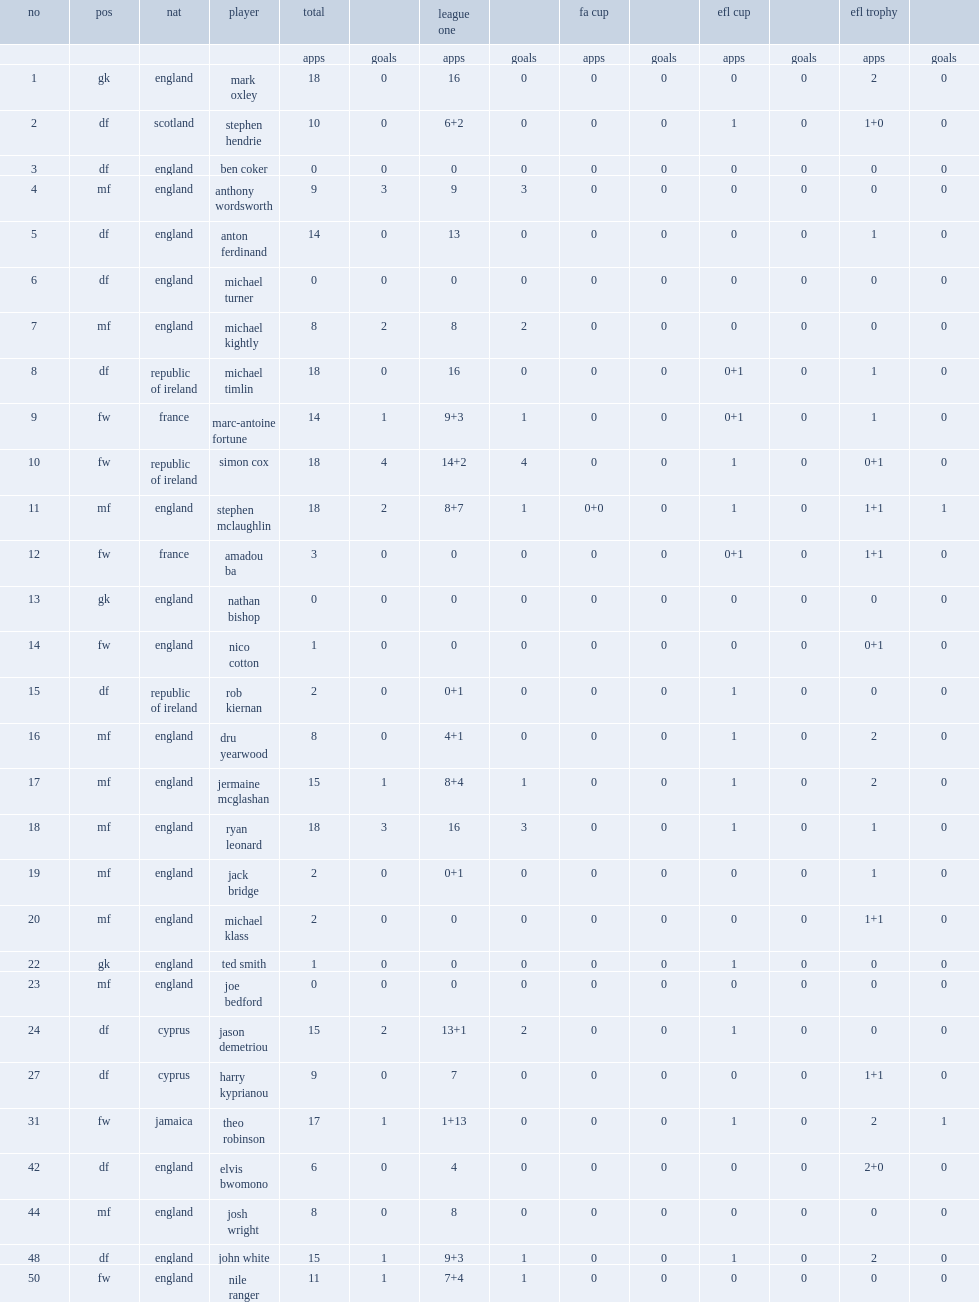Write the full table. {'header': ['no', 'pos', 'nat', 'player', 'total', '', 'league one', '', 'fa cup', '', 'efl cup', '', 'efl trophy', ''], 'rows': [['', '', '', '', 'apps', 'goals', 'apps', 'goals', 'apps', 'goals', 'apps', 'goals', 'apps', 'goals'], ['1', 'gk', 'england', 'mark oxley', '18', '0', '16', '0', '0', '0', '0', '0', '2', '0'], ['2', 'df', 'scotland', 'stephen hendrie', '10', '0', '6+2', '0', '0', '0', '1', '0', '1+0', '0'], ['3', 'df', 'england', 'ben coker', '0', '0', '0', '0', '0', '0', '0', '0', '0', '0'], ['4', 'mf', 'england', 'anthony wordsworth', '9', '3', '9', '3', '0', '0', '0', '0', '0', '0'], ['5', 'df', 'england', 'anton ferdinand', '14', '0', '13', '0', '0', '0', '0', '0', '1', '0'], ['6', 'df', 'england', 'michael turner', '0', '0', '0', '0', '0', '0', '0', '0', '0', '0'], ['7', 'mf', 'england', 'michael kightly', '8', '2', '8', '2', '0', '0', '0', '0', '0', '0'], ['8', 'df', 'republic of ireland', 'michael timlin', '18', '0', '16', '0', '0', '0', '0+1', '0', '1', '0'], ['9', 'fw', 'france', 'marc-antoine fortune', '14', '1', '9+3', '1', '0', '0', '0+1', '0', '1', '0'], ['10', 'fw', 'republic of ireland', 'simon cox', '18', '4', '14+2', '4', '0', '0', '1', '0', '0+1', '0'], ['11', 'mf', 'england', 'stephen mclaughlin', '18', '2', '8+7', '1', '0+0', '0', '1', '0', '1+1', '1'], ['12', 'fw', 'france', 'amadou ba', '3', '0', '0', '0', '0', '0', '0+1', '0', '1+1', '0'], ['13', 'gk', 'england', 'nathan bishop', '0', '0', '0', '0', '0', '0', '0', '0', '0', '0'], ['14', 'fw', 'england', 'nico cotton', '1', '0', '0', '0', '0', '0', '0', '0', '0+1', '0'], ['15', 'df', 'republic of ireland', 'rob kiernan', '2', '0', '0+1', '0', '0', '0', '1', '0', '0', '0'], ['16', 'mf', 'england', 'dru yearwood', '8', '0', '4+1', '0', '0', '0', '1', '0', '2', '0'], ['17', 'mf', 'england', 'jermaine mcglashan', '15', '1', '8+4', '1', '0', '0', '1', '0', '2', '0'], ['18', 'mf', 'england', 'ryan leonard', '18', '3', '16', '3', '0', '0', '1', '0', '1', '0'], ['19', 'mf', 'england', 'jack bridge', '2', '0', '0+1', '0', '0', '0', '0', '0', '1', '0'], ['20', 'mf', 'england', 'michael klass', '2', '0', '0', '0', '0', '0', '0', '0', '1+1', '0'], ['22', 'gk', 'england', 'ted smith', '1', '0', '0', '0', '0', '0', '1', '0', '0', '0'], ['23', 'mf', 'england', 'joe bedford', '0', '0', '0', '0', '0', '0', '0', '0', '0', '0'], ['24', 'df', 'cyprus', 'jason demetriou', '15', '2', '13+1', '2', '0', '0', '1', '0', '0', '0'], ['27', 'df', 'cyprus', 'harry kyprianou', '9', '0', '7', '0', '0', '0', '0', '0', '1+1', '0'], ['31', 'fw', 'jamaica', 'theo robinson', '17', '1', '1+13', '0', '0', '0', '1', '0', '2', '1'], ['42', 'df', 'england', 'elvis bwomono', '6', '0', '4', '0', '0', '0', '0', '0', '2+0', '0'], ['44', 'mf', 'england', 'josh wright', '8', '0', '8', '0', '0', '0', '0', '0', '0', '0'], ['48', 'df', 'england', 'john white', '15', '1', '9+3', '1', '0', '0', '1', '0', '2', '0'], ['50', 'fw', 'england', 'nile ranger', '11', '1', '7+4', '1', '0', '0', '0', '0', '0', '0']]} List the clubs southend united f.c. season participated in respectively. League one fa cup efl cup efl trophy. 